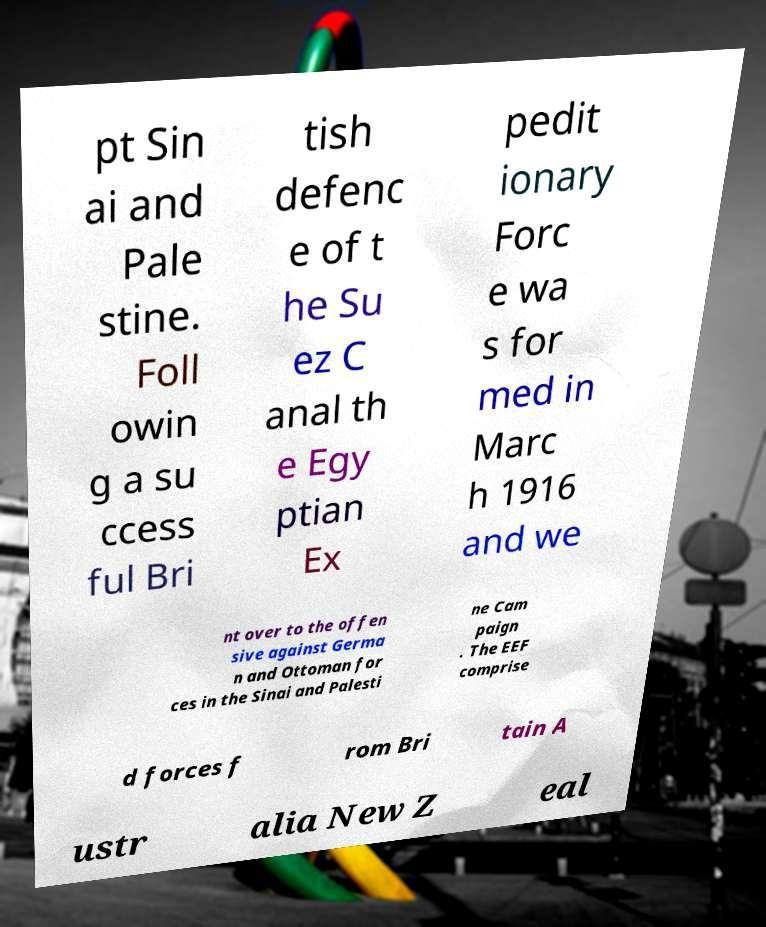There's text embedded in this image that I need extracted. Can you transcribe it verbatim? pt Sin ai and Pale stine. Foll owin g a su ccess ful Bri tish defenc e of t he Su ez C anal th e Egy ptian Ex pedit ionary Forc e wa s for med in Marc h 1916 and we nt over to the offen sive against Germa n and Ottoman for ces in the Sinai and Palesti ne Cam paign . The EEF comprise d forces f rom Bri tain A ustr alia New Z eal 